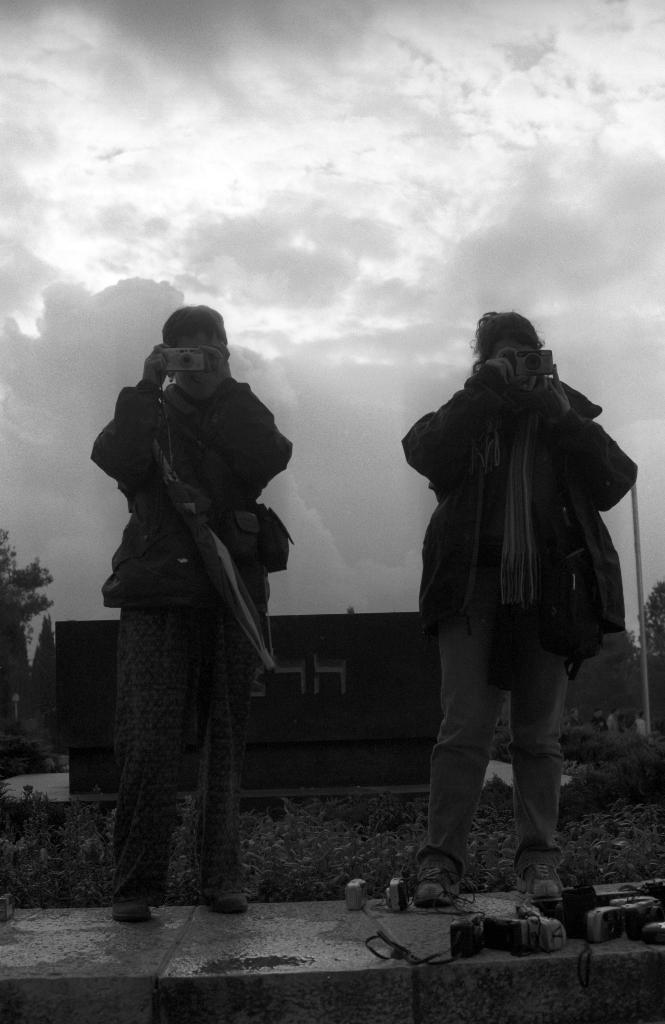What is the person on the left side of the image doing? The person is standing on the left side of the image and holding an electronic device, possibly a camera. They are trying to capture a photo. Who else is present in the image? There is a girl standing on the right side of the image. What is the girl wearing? The girl is wearing a coat. How would you describe the weather in the image? The sky is cloudy in the image. What type of vessel is being used to capture the thunder in the image? There is no vessel or thunder present in the image. The person is holding an electronic device, possibly a camera, to capture a photo. 